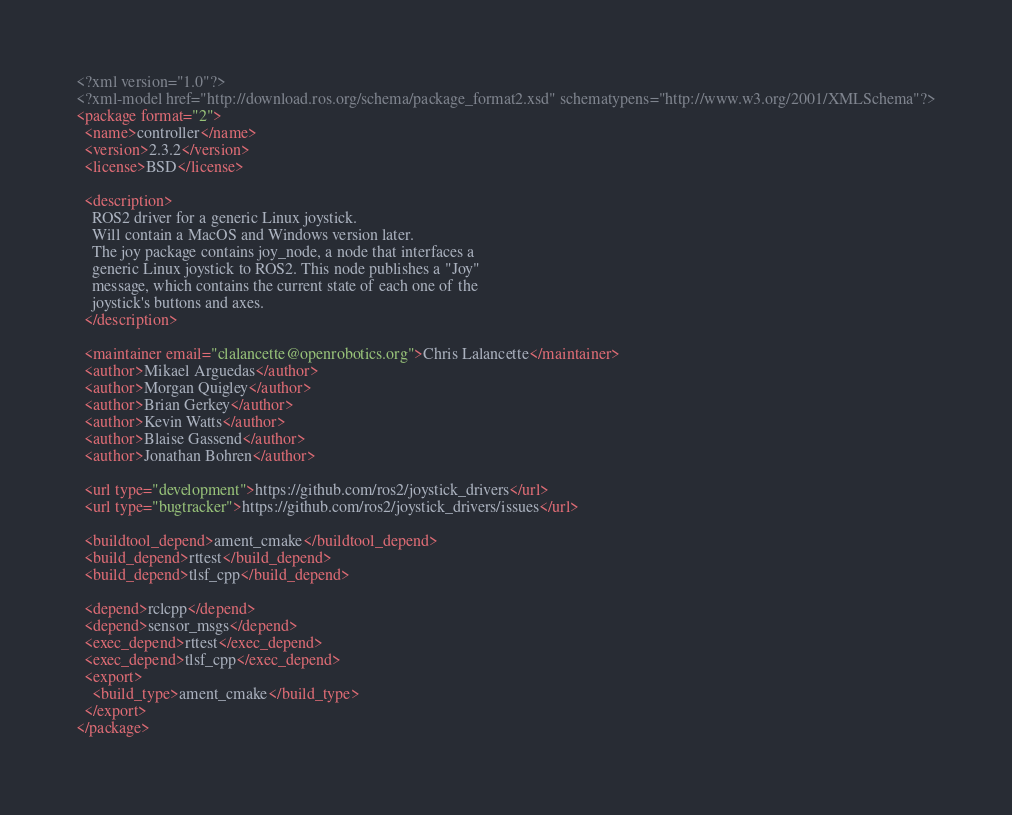Convert code to text. <code><loc_0><loc_0><loc_500><loc_500><_XML_><?xml version="1.0"?>
<?xml-model href="http://download.ros.org/schema/package_format2.xsd" schematypens="http://www.w3.org/2001/XMLSchema"?>
<package format="2">
  <name>controller</name>
  <version>2.3.2</version>
  <license>BSD</license>

  <description>
    ROS2 driver for a generic Linux joystick.
    Will contain a MacOS and Windows version later.
    The joy package contains joy_node, a node that interfaces a
    generic Linux joystick to ROS2. This node publishes a "Joy"
    message, which contains the current state of each one of the
    joystick's buttons and axes.
  </description>

  <maintainer email="clalancette@openrobotics.org">Chris Lalancette</maintainer>
  <author>Mikael Arguedas</author>
  <author>Morgan Quigley</author>
  <author>Brian Gerkey</author>
  <author>Kevin Watts</author>
  <author>Blaise Gassend</author>
  <author>Jonathan Bohren</author>

  <url type="development">https://github.com/ros2/joystick_drivers</url>
  <url type="bugtracker">https://github.com/ros2/joystick_drivers/issues</url>

  <buildtool_depend>ament_cmake</buildtool_depend>
  <build_depend>rttest</build_depend>
  <build_depend>tlsf_cpp</build_depend>
  
  <depend>rclcpp</depend>
  <depend>sensor_msgs</depend>
  <exec_depend>rttest</exec_depend>
  <exec_depend>tlsf_cpp</exec_depend>
  <export>
    <build_type>ament_cmake</build_type>
  </export>
</package>
</code> 